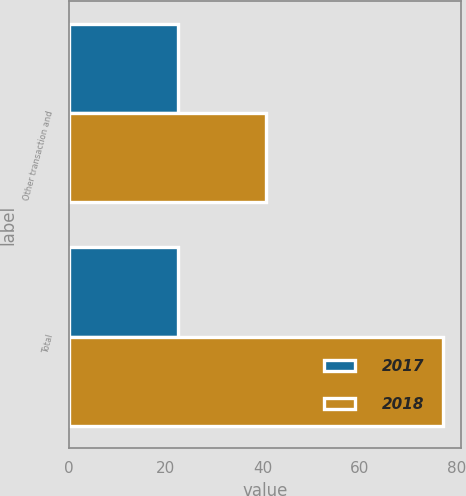Convert chart to OTSL. <chart><loc_0><loc_0><loc_500><loc_500><stacked_bar_chart><ecel><fcel>Other transaction and<fcel>Total<nl><fcel>2017<fcel>22.5<fcel>22.5<nl><fcel>2018<fcel>40.8<fcel>77.1<nl></chart> 